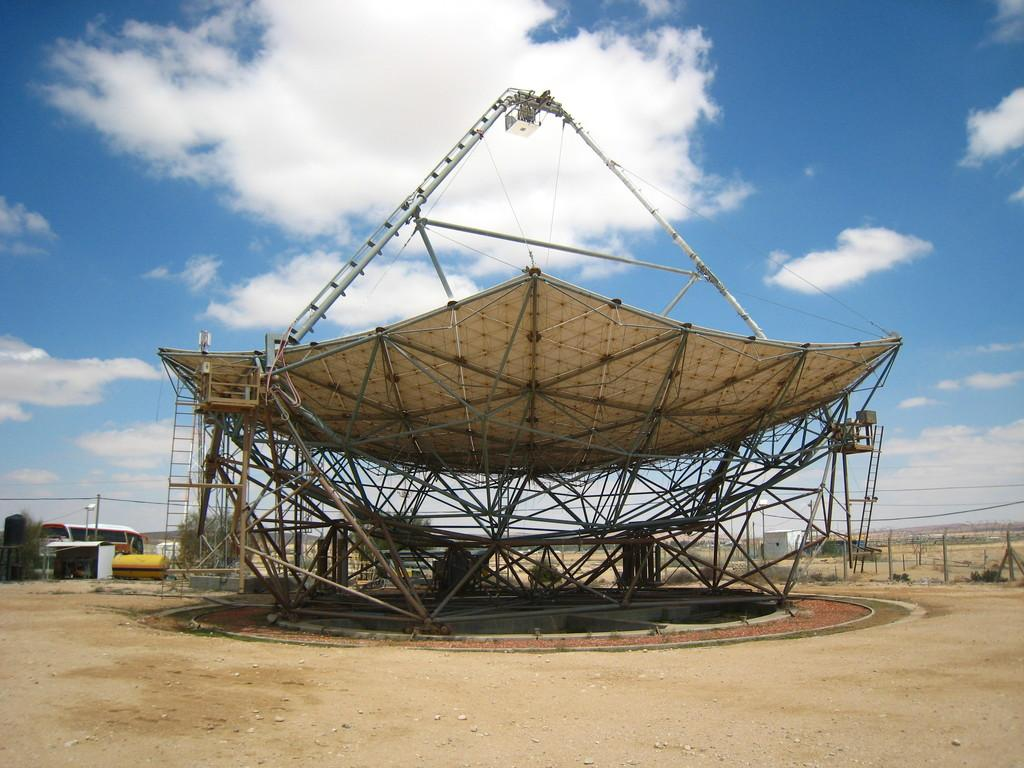What type of energy-producing device can be seen in the image? There is a solar panel in the image. What else can be seen in the image besides the solar panel? There are vehicles parked and trees visible in the image. What type of barrier is present in the image? There is a fence in the image. How would you describe the sky in the background of the image? The sky is blue with clouds in the background of the image. What idea does the actor present to the man in the image? There is no actor or man present in the image, and therefore no such interaction can be observed. 